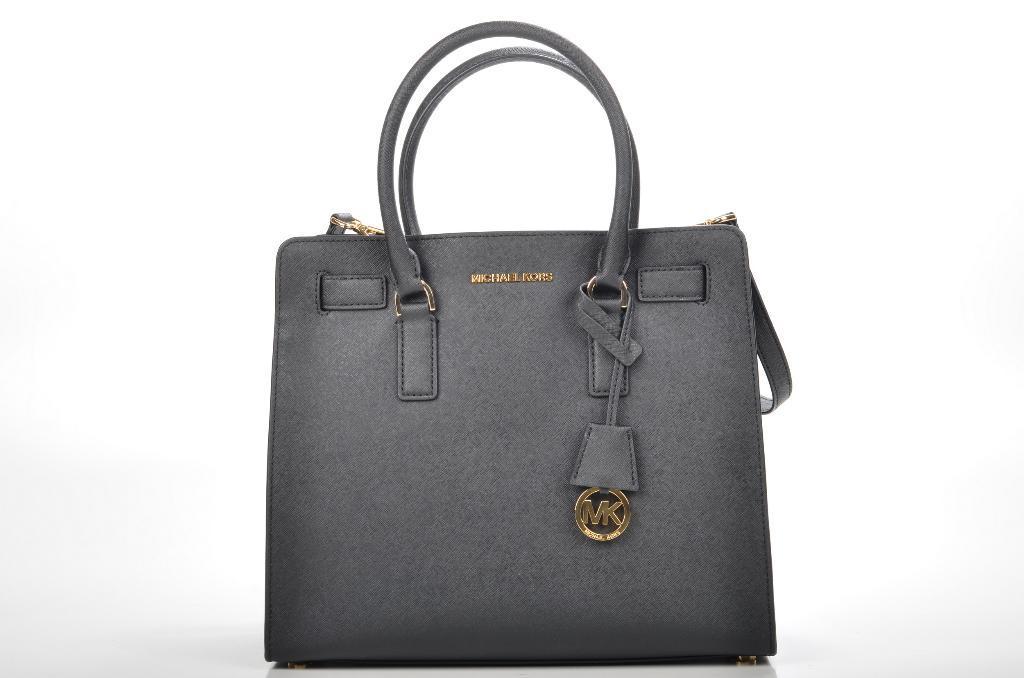Describe this image in one or two sentences. In this picture there is a handbag which is grey in color. 